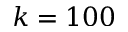<formula> <loc_0><loc_0><loc_500><loc_500>k = 1 0 0</formula> 